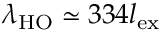<formula> <loc_0><loc_0><loc_500><loc_500>\lambda _ { H O } \simeq 3 3 4 l _ { e x }</formula> 